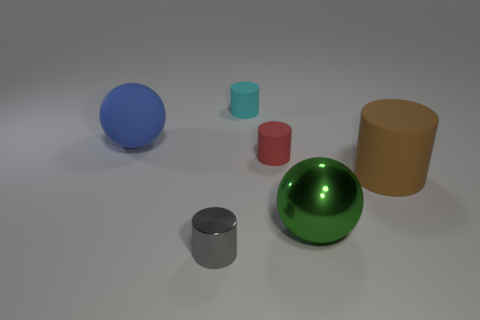How many things are small shiny things or balls to the right of the gray cylinder?
Offer a very short reply. 2. There is a matte object on the left side of the gray thing; is there a small red object that is behind it?
Provide a succinct answer. No. There is a tiny matte cylinder that is on the right side of the small cyan rubber thing; what is its color?
Offer a very short reply. Red. Are there the same number of tiny gray cylinders behind the tiny red rubber object and tiny cyan things?
Provide a short and direct response. No. What is the shape of the thing that is both to the left of the green sphere and in front of the red matte cylinder?
Your answer should be compact. Cylinder. The other large object that is the same shape as the cyan rubber thing is what color?
Give a very brief answer. Brown. What is the shape of the small matte object that is in front of the tiny cylinder that is behind the thing on the left side of the small gray metallic object?
Offer a very short reply. Cylinder. There is a sphere that is in front of the brown rubber cylinder; is it the same size as the matte cylinder on the right side of the large green ball?
Your answer should be compact. Yes. How many brown cylinders have the same material as the gray thing?
Your answer should be very brief. 0. There is a object behind the big sphere left of the green sphere; what number of tiny gray shiny things are behind it?
Give a very brief answer. 0. 